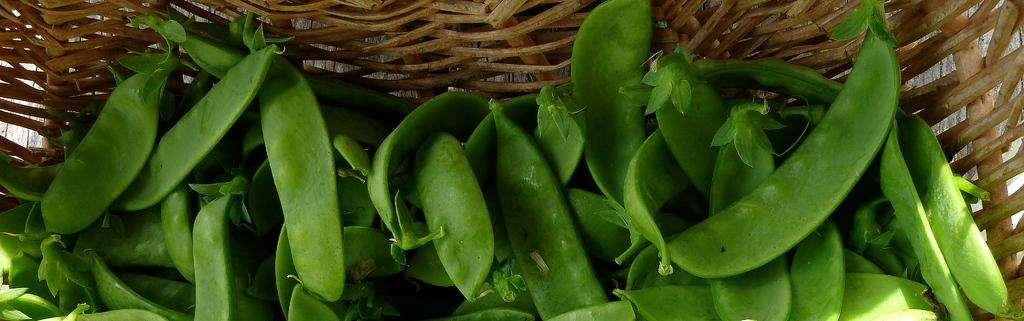What type of food can be seen in the image? There are vegetables in the image. What is the container for the vegetables made of? There is a wooden bowl in the image. What position does the monkey hold in the image? There is no monkey present in the image. 